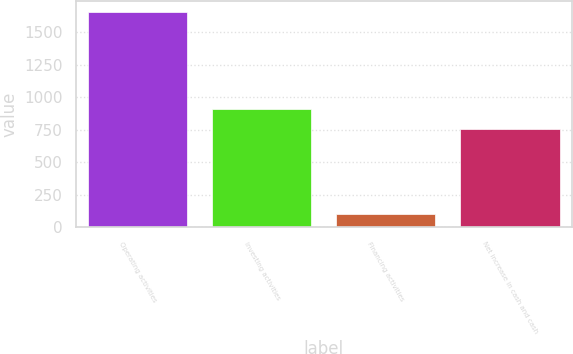Convert chart to OTSL. <chart><loc_0><loc_0><loc_500><loc_500><bar_chart><fcel>Operating activities<fcel>Investing activities<fcel>Financing activities<fcel>Net increase in cash and cash<nl><fcel>1655<fcel>910.9<fcel>106<fcel>756<nl></chart> 